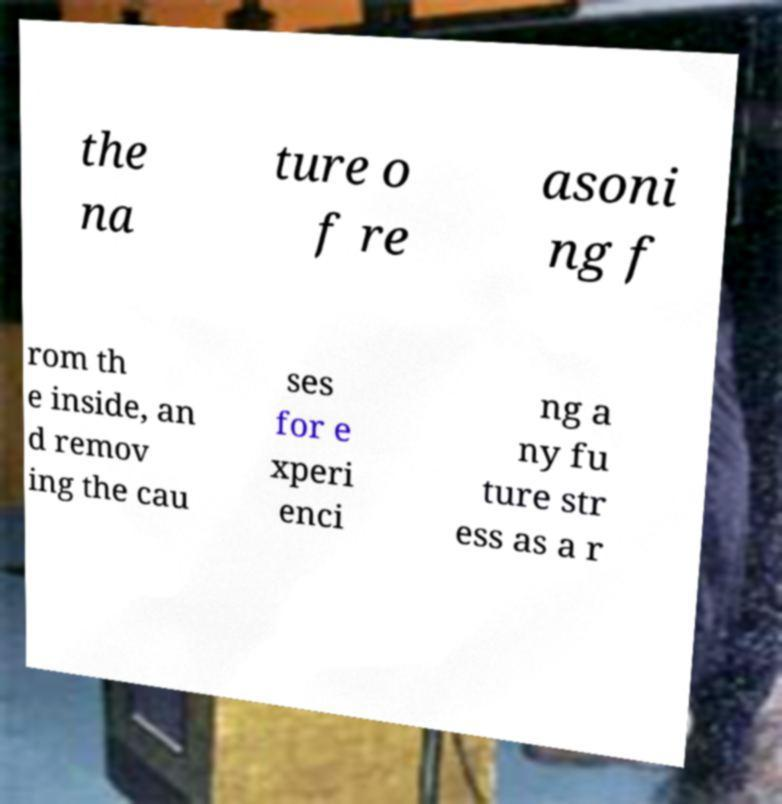Can you accurately transcribe the text from the provided image for me? the na ture o f re asoni ng f rom th e inside, an d remov ing the cau ses for e xperi enci ng a ny fu ture str ess as a r 